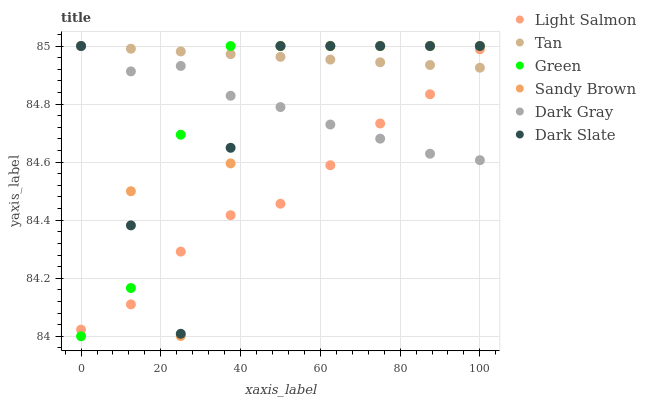Does Light Salmon have the minimum area under the curve?
Answer yes or no. Yes. Does Tan have the maximum area under the curve?
Answer yes or no. Yes. Does Dark Gray have the minimum area under the curve?
Answer yes or no. No. Does Dark Gray have the maximum area under the curve?
Answer yes or no. No. Is Tan the smoothest?
Answer yes or no. Yes. Is Dark Slate the roughest?
Answer yes or no. Yes. Is Dark Gray the smoothest?
Answer yes or no. No. Is Dark Gray the roughest?
Answer yes or no. No. Does Green have the lowest value?
Answer yes or no. Yes. Does Dark Gray have the lowest value?
Answer yes or no. No. Does Sandy Brown have the highest value?
Answer yes or no. Yes. Does Tan intersect Dark Gray?
Answer yes or no. Yes. Is Tan less than Dark Gray?
Answer yes or no. No. Is Tan greater than Dark Gray?
Answer yes or no. No. 